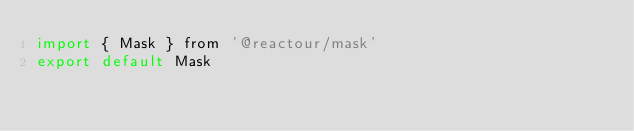Convert code to text. <code><loc_0><loc_0><loc_500><loc_500><_JavaScript_>import { Mask } from '@reactour/mask'
export default Mask
</code> 